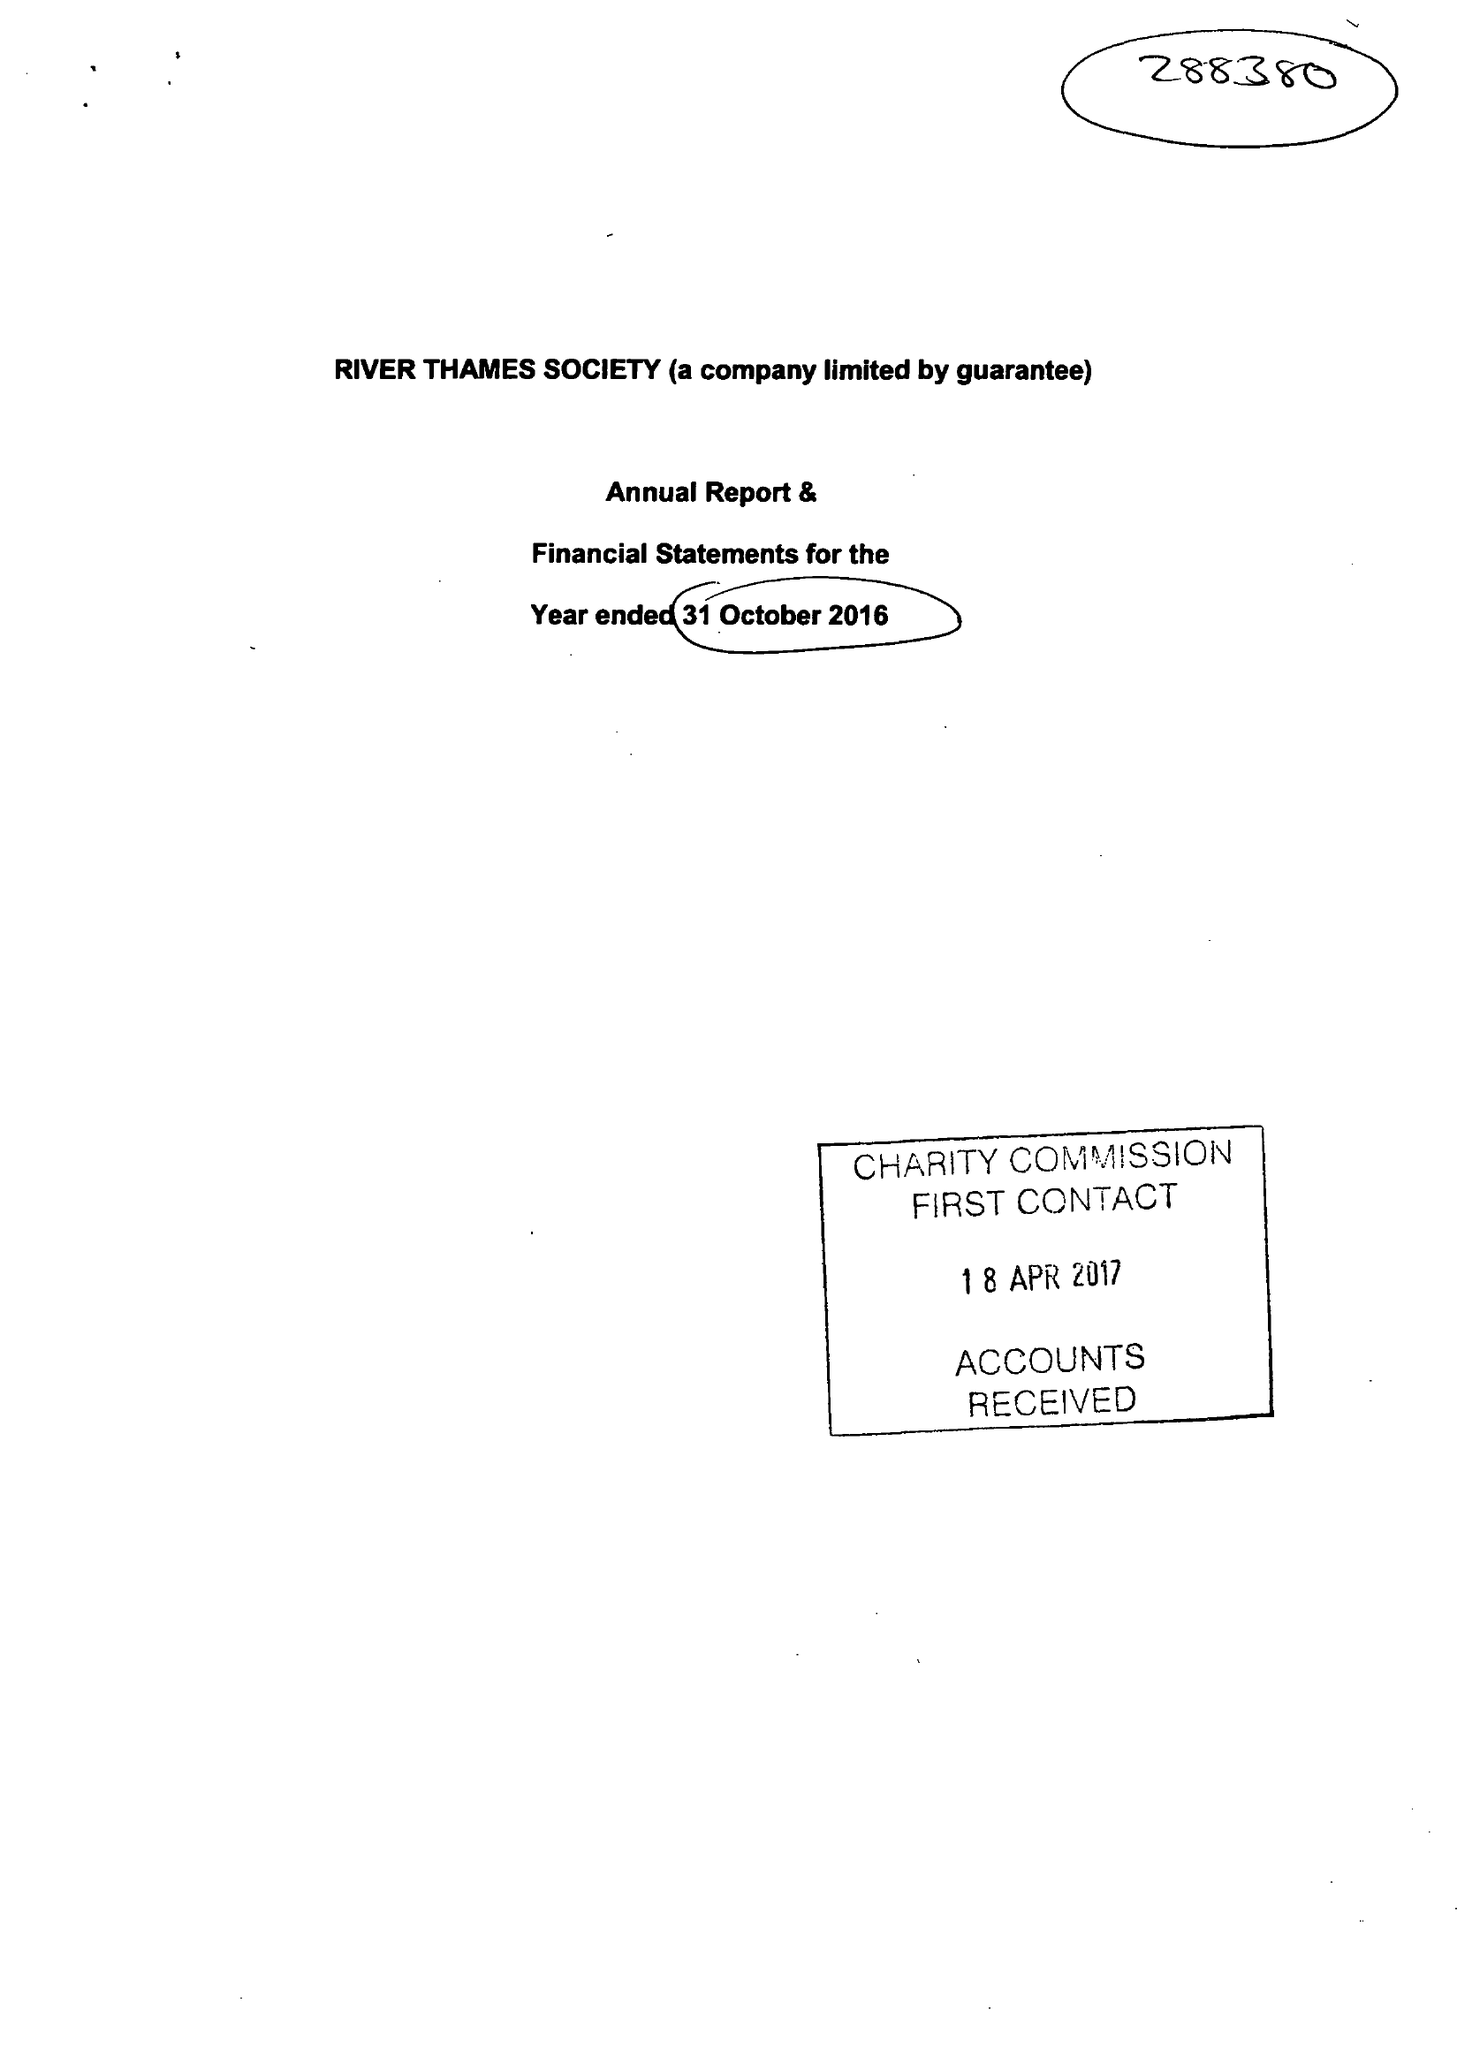What is the value for the income_annually_in_british_pounds?
Answer the question using a single word or phrase. 37344.00 